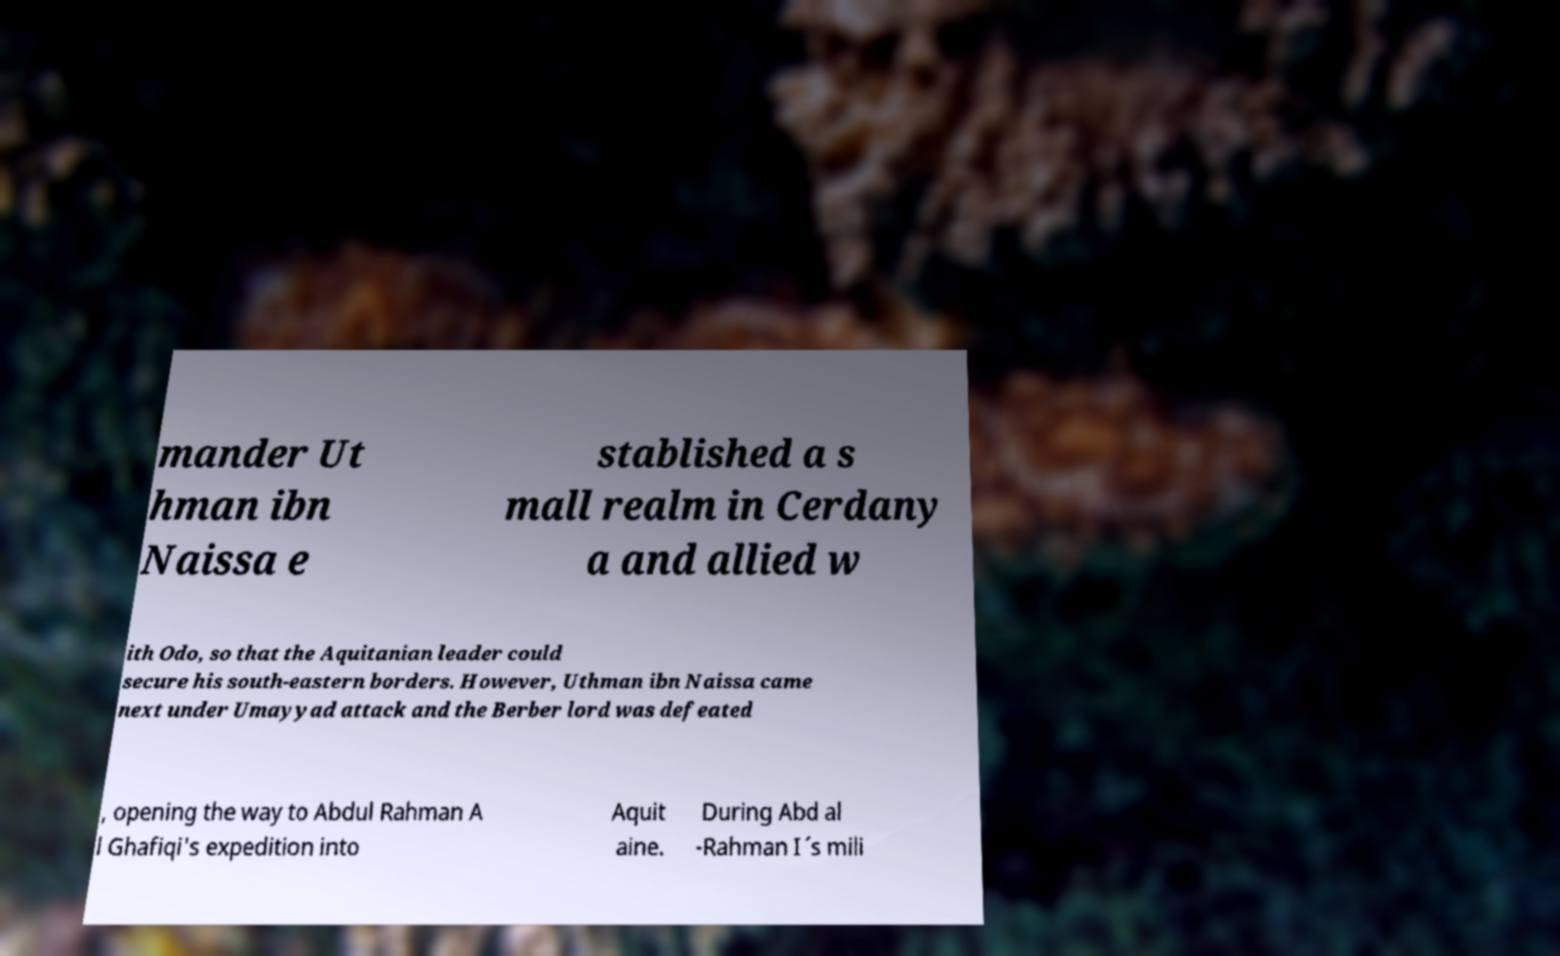Can you accurately transcribe the text from the provided image for me? mander Ut hman ibn Naissa e stablished a s mall realm in Cerdany a and allied w ith Odo, so that the Aquitanian leader could secure his south-eastern borders. However, Uthman ibn Naissa came next under Umayyad attack and the Berber lord was defeated , opening the way to Abdul Rahman A l Ghafiqi's expedition into Aquit aine. During Abd al -Rahman I´s mili 